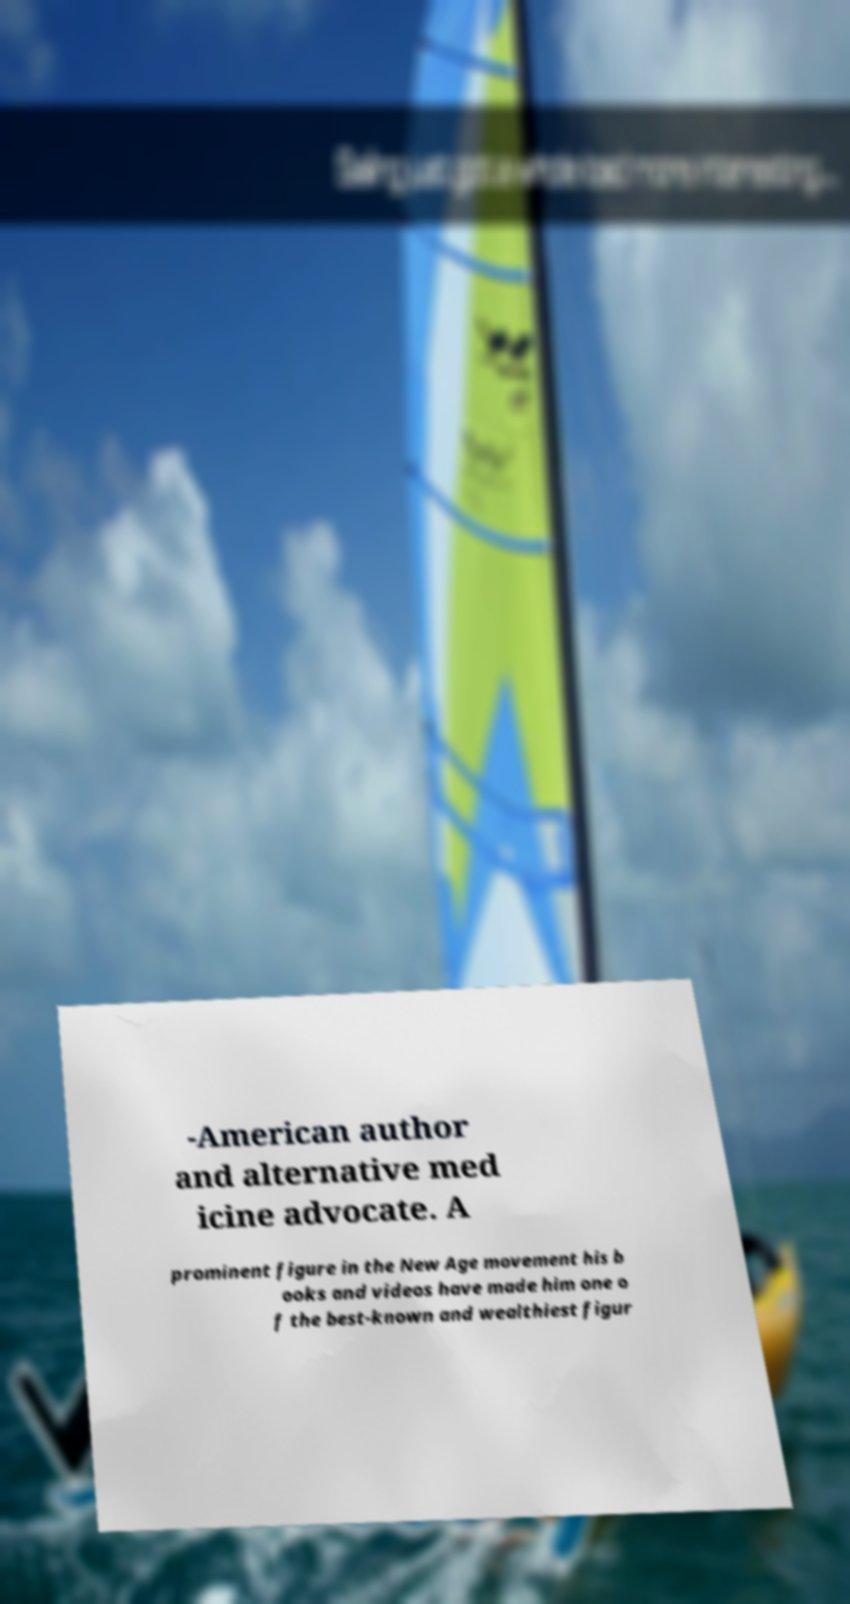There's text embedded in this image that I need extracted. Can you transcribe it verbatim? -American author and alternative med icine advocate. A prominent figure in the New Age movement his b ooks and videos have made him one o f the best-known and wealthiest figur 